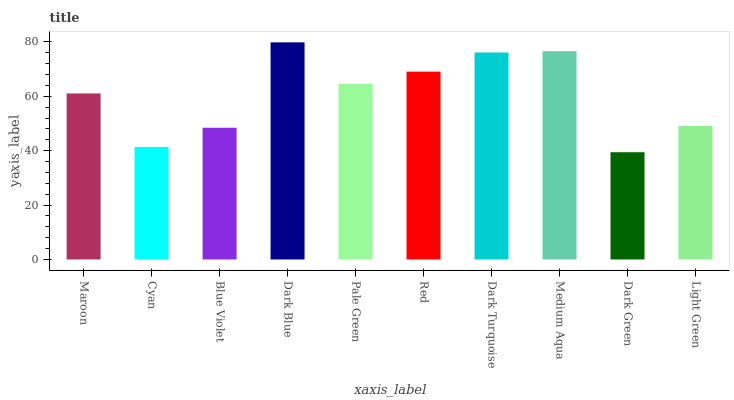Is Cyan the minimum?
Answer yes or no. No. Is Cyan the maximum?
Answer yes or no. No. Is Maroon greater than Cyan?
Answer yes or no. Yes. Is Cyan less than Maroon?
Answer yes or no. Yes. Is Cyan greater than Maroon?
Answer yes or no. No. Is Maroon less than Cyan?
Answer yes or no. No. Is Pale Green the high median?
Answer yes or no. Yes. Is Maroon the low median?
Answer yes or no. Yes. Is Dark Turquoise the high median?
Answer yes or no. No. Is Cyan the low median?
Answer yes or no. No. 